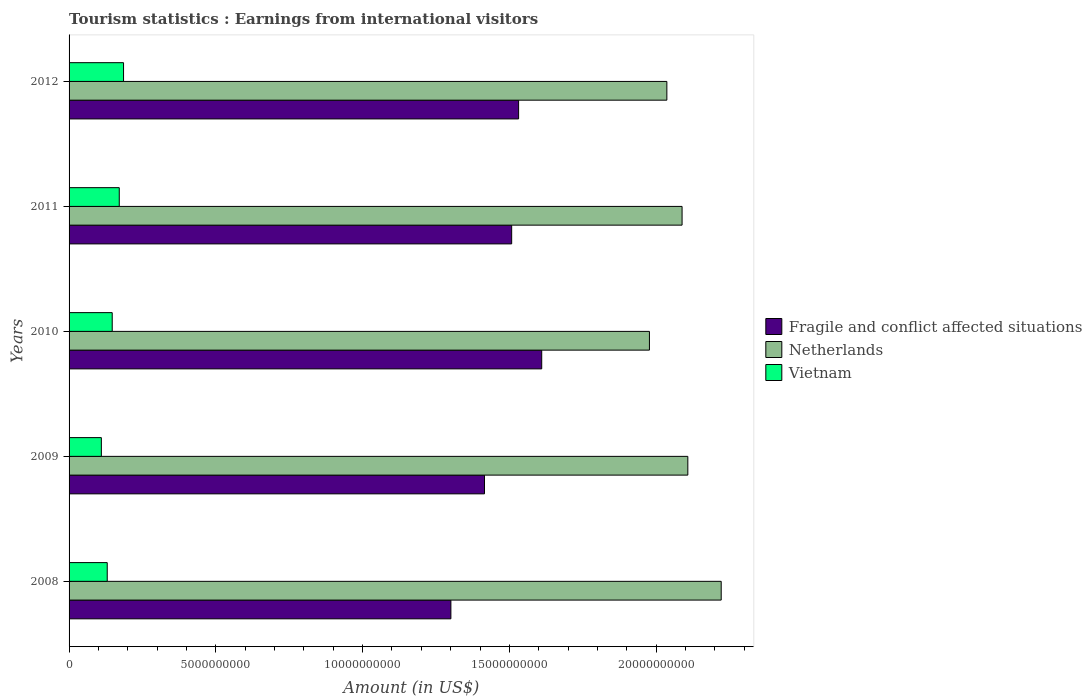Are the number of bars on each tick of the Y-axis equal?
Make the answer very short. Yes. How many bars are there on the 4th tick from the top?
Keep it short and to the point. 3. How many bars are there on the 4th tick from the bottom?
Provide a short and direct response. 3. What is the label of the 2nd group of bars from the top?
Keep it short and to the point. 2011. In how many cases, is the number of bars for a given year not equal to the number of legend labels?
Provide a short and direct response. 0. What is the earnings from international visitors in Netherlands in 2011?
Your answer should be very brief. 2.09e+1. Across all years, what is the maximum earnings from international visitors in Vietnam?
Provide a short and direct response. 1.86e+09. Across all years, what is the minimum earnings from international visitors in Vietnam?
Provide a short and direct response. 1.10e+09. In which year was the earnings from international visitors in Fragile and conflict affected situations maximum?
Your answer should be very brief. 2010. What is the total earnings from international visitors in Vietnam in the graph?
Your answer should be compact. 7.44e+09. What is the difference between the earnings from international visitors in Fragile and conflict affected situations in 2009 and that in 2010?
Your response must be concise. -1.95e+09. What is the difference between the earnings from international visitors in Netherlands in 2009 and the earnings from international visitors in Fragile and conflict affected situations in 2011?
Make the answer very short. 6.00e+09. What is the average earnings from international visitors in Fragile and conflict affected situations per year?
Provide a succinct answer. 1.47e+1. In the year 2011, what is the difference between the earnings from international visitors in Netherlands and earnings from international visitors in Fragile and conflict affected situations?
Make the answer very short. 5.81e+09. What is the ratio of the earnings from international visitors in Fragile and conflict affected situations in 2008 to that in 2012?
Your answer should be compact. 0.85. Is the earnings from international visitors in Netherlands in 2008 less than that in 2012?
Your answer should be very brief. No. Is the difference between the earnings from international visitors in Netherlands in 2009 and 2011 greater than the difference between the earnings from international visitors in Fragile and conflict affected situations in 2009 and 2011?
Offer a terse response. Yes. What is the difference between the highest and the second highest earnings from international visitors in Fragile and conflict affected situations?
Your answer should be compact. 7.87e+08. What is the difference between the highest and the lowest earnings from international visitors in Netherlands?
Ensure brevity in your answer.  2.44e+09. In how many years, is the earnings from international visitors in Fragile and conflict affected situations greater than the average earnings from international visitors in Fragile and conflict affected situations taken over all years?
Your response must be concise. 3. Is the sum of the earnings from international visitors in Vietnam in 2008 and 2011 greater than the maximum earnings from international visitors in Netherlands across all years?
Keep it short and to the point. No. What does the 1st bar from the bottom in 2008 represents?
Offer a very short reply. Fragile and conflict affected situations. What is the difference between two consecutive major ticks on the X-axis?
Offer a very short reply. 5.00e+09. Does the graph contain grids?
Give a very brief answer. No. How many legend labels are there?
Offer a very short reply. 3. How are the legend labels stacked?
Provide a short and direct response. Vertical. What is the title of the graph?
Keep it short and to the point. Tourism statistics : Earnings from international visitors. What is the label or title of the X-axis?
Make the answer very short. Amount (in US$). What is the label or title of the Y-axis?
Make the answer very short. Years. What is the Amount (in US$) of Fragile and conflict affected situations in 2008?
Offer a terse response. 1.30e+1. What is the Amount (in US$) of Netherlands in 2008?
Provide a short and direct response. 2.22e+1. What is the Amount (in US$) in Vietnam in 2008?
Provide a short and direct response. 1.30e+09. What is the Amount (in US$) in Fragile and conflict affected situations in 2009?
Offer a very short reply. 1.42e+1. What is the Amount (in US$) of Netherlands in 2009?
Your response must be concise. 2.11e+1. What is the Amount (in US$) in Vietnam in 2009?
Provide a short and direct response. 1.10e+09. What is the Amount (in US$) of Fragile and conflict affected situations in 2010?
Your answer should be compact. 1.61e+1. What is the Amount (in US$) in Netherlands in 2010?
Offer a very short reply. 1.98e+1. What is the Amount (in US$) of Vietnam in 2010?
Provide a succinct answer. 1.47e+09. What is the Amount (in US$) of Fragile and conflict affected situations in 2011?
Make the answer very short. 1.51e+1. What is the Amount (in US$) in Netherlands in 2011?
Your answer should be compact. 2.09e+1. What is the Amount (in US$) of Vietnam in 2011?
Your response must be concise. 1.71e+09. What is the Amount (in US$) in Fragile and conflict affected situations in 2012?
Offer a terse response. 1.53e+1. What is the Amount (in US$) of Netherlands in 2012?
Ensure brevity in your answer.  2.04e+1. What is the Amount (in US$) of Vietnam in 2012?
Give a very brief answer. 1.86e+09. Across all years, what is the maximum Amount (in US$) in Fragile and conflict affected situations?
Offer a very short reply. 1.61e+1. Across all years, what is the maximum Amount (in US$) in Netherlands?
Make the answer very short. 2.22e+1. Across all years, what is the maximum Amount (in US$) in Vietnam?
Offer a very short reply. 1.86e+09. Across all years, what is the minimum Amount (in US$) in Fragile and conflict affected situations?
Offer a terse response. 1.30e+1. Across all years, what is the minimum Amount (in US$) of Netherlands?
Your answer should be compact. 1.98e+1. Across all years, what is the minimum Amount (in US$) in Vietnam?
Give a very brief answer. 1.10e+09. What is the total Amount (in US$) of Fragile and conflict affected situations in the graph?
Offer a very short reply. 7.37e+1. What is the total Amount (in US$) in Netherlands in the graph?
Provide a short and direct response. 1.04e+11. What is the total Amount (in US$) of Vietnam in the graph?
Make the answer very short. 7.44e+09. What is the difference between the Amount (in US$) of Fragile and conflict affected situations in 2008 and that in 2009?
Your answer should be very brief. -1.14e+09. What is the difference between the Amount (in US$) in Netherlands in 2008 and that in 2009?
Provide a short and direct response. 1.14e+09. What is the difference between the Amount (in US$) of Vietnam in 2008 and that in 2009?
Provide a short and direct response. 2.00e+08. What is the difference between the Amount (in US$) of Fragile and conflict affected situations in 2008 and that in 2010?
Give a very brief answer. -3.09e+09. What is the difference between the Amount (in US$) of Netherlands in 2008 and that in 2010?
Your answer should be very brief. 2.44e+09. What is the difference between the Amount (in US$) of Vietnam in 2008 and that in 2010?
Your response must be concise. -1.70e+08. What is the difference between the Amount (in US$) in Fragile and conflict affected situations in 2008 and that in 2011?
Keep it short and to the point. -2.07e+09. What is the difference between the Amount (in US$) in Netherlands in 2008 and that in 2011?
Make the answer very short. 1.33e+09. What is the difference between the Amount (in US$) in Vietnam in 2008 and that in 2011?
Provide a succinct answer. -4.10e+08. What is the difference between the Amount (in US$) of Fragile and conflict affected situations in 2008 and that in 2012?
Make the answer very short. -2.31e+09. What is the difference between the Amount (in US$) of Netherlands in 2008 and that in 2012?
Give a very brief answer. 1.85e+09. What is the difference between the Amount (in US$) of Vietnam in 2008 and that in 2012?
Ensure brevity in your answer.  -5.56e+08. What is the difference between the Amount (in US$) in Fragile and conflict affected situations in 2009 and that in 2010?
Your answer should be very brief. -1.95e+09. What is the difference between the Amount (in US$) in Netherlands in 2009 and that in 2010?
Your answer should be very brief. 1.31e+09. What is the difference between the Amount (in US$) of Vietnam in 2009 and that in 2010?
Your response must be concise. -3.70e+08. What is the difference between the Amount (in US$) in Fragile and conflict affected situations in 2009 and that in 2011?
Provide a short and direct response. -9.26e+08. What is the difference between the Amount (in US$) in Netherlands in 2009 and that in 2011?
Ensure brevity in your answer.  1.96e+08. What is the difference between the Amount (in US$) in Vietnam in 2009 and that in 2011?
Give a very brief answer. -6.10e+08. What is the difference between the Amount (in US$) in Fragile and conflict affected situations in 2009 and that in 2012?
Provide a succinct answer. -1.16e+09. What is the difference between the Amount (in US$) in Netherlands in 2009 and that in 2012?
Your response must be concise. 7.14e+08. What is the difference between the Amount (in US$) of Vietnam in 2009 and that in 2012?
Your answer should be very brief. -7.56e+08. What is the difference between the Amount (in US$) of Fragile and conflict affected situations in 2010 and that in 2011?
Keep it short and to the point. 1.02e+09. What is the difference between the Amount (in US$) in Netherlands in 2010 and that in 2011?
Offer a very short reply. -1.11e+09. What is the difference between the Amount (in US$) of Vietnam in 2010 and that in 2011?
Provide a succinct answer. -2.40e+08. What is the difference between the Amount (in US$) in Fragile and conflict affected situations in 2010 and that in 2012?
Keep it short and to the point. 7.87e+08. What is the difference between the Amount (in US$) of Netherlands in 2010 and that in 2012?
Make the answer very short. -5.94e+08. What is the difference between the Amount (in US$) in Vietnam in 2010 and that in 2012?
Provide a succinct answer. -3.86e+08. What is the difference between the Amount (in US$) in Fragile and conflict affected situations in 2011 and that in 2012?
Keep it short and to the point. -2.37e+08. What is the difference between the Amount (in US$) of Netherlands in 2011 and that in 2012?
Your answer should be compact. 5.18e+08. What is the difference between the Amount (in US$) in Vietnam in 2011 and that in 2012?
Offer a very short reply. -1.46e+08. What is the difference between the Amount (in US$) of Fragile and conflict affected situations in 2008 and the Amount (in US$) of Netherlands in 2009?
Give a very brief answer. -8.07e+09. What is the difference between the Amount (in US$) of Fragile and conflict affected situations in 2008 and the Amount (in US$) of Vietnam in 2009?
Offer a very short reply. 1.19e+1. What is the difference between the Amount (in US$) in Netherlands in 2008 and the Amount (in US$) in Vietnam in 2009?
Make the answer very short. 2.11e+1. What is the difference between the Amount (in US$) in Fragile and conflict affected situations in 2008 and the Amount (in US$) in Netherlands in 2010?
Your answer should be compact. -6.76e+09. What is the difference between the Amount (in US$) in Fragile and conflict affected situations in 2008 and the Amount (in US$) in Vietnam in 2010?
Your response must be concise. 1.15e+1. What is the difference between the Amount (in US$) of Netherlands in 2008 and the Amount (in US$) of Vietnam in 2010?
Your answer should be compact. 2.07e+1. What is the difference between the Amount (in US$) in Fragile and conflict affected situations in 2008 and the Amount (in US$) in Netherlands in 2011?
Keep it short and to the point. -7.88e+09. What is the difference between the Amount (in US$) of Fragile and conflict affected situations in 2008 and the Amount (in US$) of Vietnam in 2011?
Provide a succinct answer. 1.13e+1. What is the difference between the Amount (in US$) of Netherlands in 2008 and the Amount (in US$) of Vietnam in 2011?
Provide a succinct answer. 2.05e+1. What is the difference between the Amount (in US$) in Fragile and conflict affected situations in 2008 and the Amount (in US$) in Netherlands in 2012?
Provide a succinct answer. -7.36e+09. What is the difference between the Amount (in US$) in Fragile and conflict affected situations in 2008 and the Amount (in US$) in Vietnam in 2012?
Your response must be concise. 1.12e+1. What is the difference between the Amount (in US$) of Netherlands in 2008 and the Amount (in US$) of Vietnam in 2012?
Offer a terse response. 2.04e+1. What is the difference between the Amount (in US$) in Fragile and conflict affected situations in 2009 and the Amount (in US$) in Netherlands in 2010?
Ensure brevity in your answer.  -5.62e+09. What is the difference between the Amount (in US$) in Fragile and conflict affected situations in 2009 and the Amount (in US$) in Vietnam in 2010?
Your answer should be compact. 1.27e+1. What is the difference between the Amount (in US$) in Netherlands in 2009 and the Amount (in US$) in Vietnam in 2010?
Give a very brief answer. 1.96e+1. What is the difference between the Amount (in US$) of Fragile and conflict affected situations in 2009 and the Amount (in US$) of Netherlands in 2011?
Offer a terse response. -6.73e+09. What is the difference between the Amount (in US$) of Fragile and conflict affected situations in 2009 and the Amount (in US$) of Vietnam in 2011?
Ensure brevity in your answer.  1.24e+1. What is the difference between the Amount (in US$) in Netherlands in 2009 and the Amount (in US$) in Vietnam in 2011?
Make the answer very short. 1.94e+1. What is the difference between the Amount (in US$) of Fragile and conflict affected situations in 2009 and the Amount (in US$) of Netherlands in 2012?
Keep it short and to the point. -6.21e+09. What is the difference between the Amount (in US$) in Fragile and conflict affected situations in 2009 and the Amount (in US$) in Vietnam in 2012?
Your answer should be very brief. 1.23e+1. What is the difference between the Amount (in US$) of Netherlands in 2009 and the Amount (in US$) of Vietnam in 2012?
Your answer should be very brief. 1.92e+1. What is the difference between the Amount (in US$) of Fragile and conflict affected situations in 2010 and the Amount (in US$) of Netherlands in 2011?
Give a very brief answer. -4.78e+09. What is the difference between the Amount (in US$) of Fragile and conflict affected situations in 2010 and the Amount (in US$) of Vietnam in 2011?
Provide a succinct answer. 1.44e+1. What is the difference between the Amount (in US$) in Netherlands in 2010 and the Amount (in US$) in Vietnam in 2011?
Offer a very short reply. 1.81e+1. What is the difference between the Amount (in US$) in Fragile and conflict affected situations in 2010 and the Amount (in US$) in Netherlands in 2012?
Offer a very short reply. -4.26e+09. What is the difference between the Amount (in US$) in Fragile and conflict affected situations in 2010 and the Amount (in US$) in Vietnam in 2012?
Keep it short and to the point. 1.42e+1. What is the difference between the Amount (in US$) of Netherlands in 2010 and the Amount (in US$) of Vietnam in 2012?
Ensure brevity in your answer.  1.79e+1. What is the difference between the Amount (in US$) in Fragile and conflict affected situations in 2011 and the Amount (in US$) in Netherlands in 2012?
Your answer should be compact. -5.29e+09. What is the difference between the Amount (in US$) in Fragile and conflict affected situations in 2011 and the Amount (in US$) in Vietnam in 2012?
Your answer should be compact. 1.32e+1. What is the difference between the Amount (in US$) of Netherlands in 2011 and the Amount (in US$) of Vietnam in 2012?
Your answer should be very brief. 1.90e+1. What is the average Amount (in US$) of Fragile and conflict affected situations per year?
Your answer should be very brief. 1.47e+1. What is the average Amount (in US$) in Netherlands per year?
Ensure brevity in your answer.  2.09e+1. What is the average Amount (in US$) in Vietnam per year?
Make the answer very short. 1.49e+09. In the year 2008, what is the difference between the Amount (in US$) in Fragile and conflict affected situations and Amount (in US$) in Netherlands?
Provide a short and direct response. -9.21e+09. In the year 2008, what is the difference between the Amount (in US$) in Fragile and conflict affected situations and Amount (in US$) in Vietnam?
Your answer should be very brief. 1.17e+1. In the year 2008, what is the difference between the Amount (in US$) of Netherlands and Amount (in US$) of Vietnam?
Provide a short and direct response. 2.09e+1. In the year 2009, what is the difference between the Amount (in US$) in Fragile and conflict affected situations and Amount (in US$) in Netherlands?
Keep it short and to the point. -6.93e+09. In the year 2009, what is the difference between the Amount (in US$) in Fragile and conflict affected situations and Amount (in US$) in Vietnam?
Provide a succinct answer. 1.31e+1. In the year 2009, what is the difference between the Amount (in US$) in Netherlands and Amount (in US$) in Vietnam?
Give a very brief answer. 2.00e+1. In the year 2010, what is the difference between the Amount (in US$) of Fragile and conflict affected situations and Amount (in US$) of Netherlands?
Offer a terse response. -3.67e+09. In the year 2010, what is the difference between the Amount (in US$) in Fragile and conflict affected situations and Amount (in US$) in Vietnam?
Offer a terse response. 1.46e+1. In the year 2010, what is the difference between the Amount (in US$) in Netherlands and Amount (in US$) in Vietnam?
Your response must be concise. 1.83e+1. In the year 2011, what is the difference between the Amount (in US$) of Fragile and conflict affected situations and Amount (in US$) of Netherlands?
Provide a succinct answer. -5.81e+09. In the year 2011, what is the difference between the Amount (in US$) in Fragile and conflict affected situations and Amount (in US$) in Vietnam?
Give a very brief answer. 1.34e+1. In the year 2011, what is the difference between the Amount (in US$) in Netherlands and Amount (in US$) in Vietnam?
Your answer should be very brief. 1.92e+1. In the year 2012, what is the difference between the Amount (in US$) of Fragile and conflict affected situations and Amount (in US$) of Netherlands?
Keep it short and to the point. -5.05e+09. In the year 2012, what is the difference between the Amount (in US$) of Fragile and conflict affected situations and Amount (in US$) of Vietnam?
Offer a terse response. 1.35e+1. In the year 2012, what is the difference between the Amount (in US$) in Netherlands and Amount (in US$) in Vietnam?
Offer a very short reply. 1.85e+1. What is the ratio of the Amount (in US$) in Fragile and conflict affected situations in 2008 to that in 2009?
Give a very brief answer. 0.92. What is the ratio of the Amount (in US$) in Netherlands in 2008 to that in 2009?
Offer a terse response. 1.05. What is the ratio of the Amount (in US$) in Vietnam in 2008 to that in 2009?
Your answer should be compact. 1.18. What is the ratio of the Amount (in US$) in Fragile and conflict affected situations in 2008 to that in 2010?
Give a very brief answer. 0.81. What is the ratio of the Amount (in US$) in Netherlands in 2008 to that in 2010?
Offer a terse response. 1.12. What is the ratio of the Amount (in US$) in Vietnam in 2008 to that in 2010?
Offer a terse response. 0.88. What is the ratio of the Amount (in US$) of Fragile and conflict affected situations in 2008 to that in 2011?
Provide a succinct answer. 0.86. What is the ratio of the Amount (in US$) of Netherlands in 2008 to that in 2011?
Your response must be concise. 1.06. What is the ratio of the Amount (in US$) of Vietnam in 2008 to that in 2011?
Provide a short and direct response. 0.76. What is the ratio of the Amount (in US$) in Fragile and conflict affected situations in 2008 to that in 2012?
Your response must be concise. 0.85. What is the ratio of the Amount (in US$) of Netherlands in 2008 to that in 2012?
Your answer should be compact. 1.09. What is the ratio of the Amount (in US$) in Vietnam in 2008 to that in 2012?
Your response must be concise. 0.7. What is the ratio of the Amount (in US$) in Fragile and conflict affected situations in 2009 to that in 2010?
Offer a terse response. 0.88. What is the ratio of the Amount (in US$) in Netherlands in 2009 to that in 2010?
Your answer should be compact. 1.07. What is the ratio of the Amount (in US$) in Vietnam in 2009 to that in 2010?
Keep it short and to the point. 0.75. What is the ratio of the Amount (in US$) of Fragile and conflict affected situations in 2009 to that in 2011?
Your answer should be very brief. 0.94. What is the ratio of the Amount (in US$) in Netherlands in 2009 to that in 2011?
Give a very brief answer. 1.01. What is the ratio of the Amount (in US$) in Vietnam in 2009 to that in 2011?
Make the answer very short. 0.64. What is the ratio of the Amount (in US$) of Fragile and conflict affected situations in 2009 to that in 2012?
Your response must be concise. 0.92. What is the ratio of the Amount (in US$) in Netherlands in 2009 to that in 2012?
Keep it short and to the point. 1.04. What is the ratio of the Amount (in US$) of Vietnam in 2009 to that in 2012?
Keep it short and to the point. 0.59. What is the ratio of the Amount (in US$) of Fragile and conflict affected situations in 2010 to that in 2011?
Your response must be concise. 1.07. What is the ratio of the Amount (in US$) in Netherlands in 2010 to that in 2011?
Your response must be concise. 0.95. What is the ratio of the Amount (in US$) in Vietnam in 2010 to that in 2011?
Keep it short and to the point. 0.86. What is the ratio of the Amount (in US$) in Fragile and conflict affected situations in 2010 to that in 2012?
Provide a short and direct response. 1.05. What is the ratio of the Amount (in US$) in Netherlands in 2010 to that in 2012?
Offer a terse response. 0.97. What is the ratio of the Amount (in US$) in Vietnam in 2010 to that in 2012?
Provide a short and direct response. 0.79. What is the ratio of the Amount (in US$) in Fragile and conflict affected situations in 2011 to that in 2012?
Ensure brevity in your answer.  0.98. What is the ratio of the Amount (in US$) in Netherlands in 2011 to that in 2012?
Your answer should be compact. 1.03. What is the ratio of the Amount (in US$) of Vietnam in 2011 to that in 2012?
Your response must be concise. 0.92. What is the difference between the highest and the second highest Amount (in US$) of Fragile and conflict affected situations?
Offer a terse response. 7.87e+08. What is the difference between the highest and the second highest Amount (in US$) in Netherlands?
Provide a succinct answer. 1.14e+09. What is the difference between the highest and the second highest Amount (in US$) of Vietnam?
Provide a short and direct response. 1.46e+08. What is the difference between the highest and the lowest Amount (in US$) of Fragile and conflict affected situations?
Your answer should be very brief. 3.09e+09. What is the difference between the highest and the lowest Amount (in US$) of Netherlands?
Keep it short and to the point. 2.44e+09. What is the difference between the highest and the lowest Amount (in US$) of Vietnam?
Your response must be concise. 7.56e+08. 